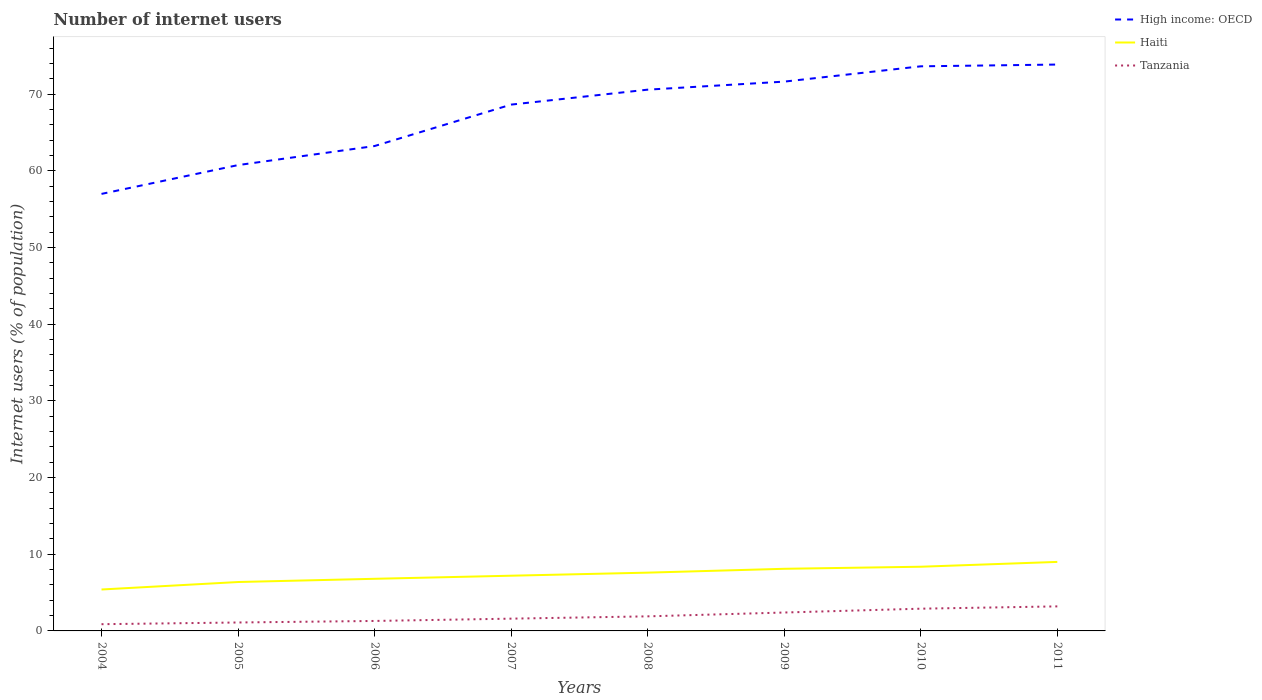How many different coloured lines are there?
Offer a terse response. 3. Does the line corresponding to High income: OECD intersect with the line corresponding to Haiti?
Your answer should be compact. No. Is the number of lines equal to the number of legend labels?
Your answer should be very brief. Yes. Across all years, what is the maximum number of internet users in High income: OECD?
Provide a short and direct response. 56.99. What is the total number of internet users in High income: OECD in the graph?
Your answer should be very brief. -0.23. What is the difference between the highest and the second highest number of internet users in High income: OECD?
Provide a short and direct response. 16.87. Are the values on the major ticks of Y-axis written in scientific E-notation?
Offer a very short reply. No. How many legend labels are there?
Offer a very short reply. 3. How are the legend labels stacked?
Keep it short and to the point. Vertical. What is the title of the graph?
Give a very brief answer. Number of internet users. Does "Morocco" appear as one of the legend labels in the graph?
Provide a short and direct response. No. What is the label or title of the X-axis?
Give a very brief answer. Years. What is the label or title of the Y-axis?
Ensure brevity in your answer.  Internet users (% of population). What is the Internet users (% of population) of High income: OECD in 2004?
Offer a very short reply. 56.99. What is the Internet users (% of population) of Haiti in 2004?
Your answer should be very brief. 5.4. What is the Internet users (% of population) of Tanzania in 2004?
Your answer should be very brief. 0.88. What is the Internet users (% of population) in High income: OECD in 2005?
Ensure brevity in your answer.  60.74. What is the Internet users (% of population) of Haiti in 2005?
Provide a succinct answer. 6.38. What is the Internet users (% of population) in Tanzania in 2005?
Provide a succinct answer. 1.1. What is the Internet users (% of population) in High income: OECD in 2006?
Your answer should be compact. 63.23. What is the Internet users (% of population) in Haiti in 2006?
Ensure brevity in your answer.  6.8. What is the Internet users (% of population) of High income: OECD in 2007?
Offer a terse response. 68.63. What is the Internet users (% of population) in High income: OECD in 2008?
Your answer should be compact. 70.58. What is the Internet users (% of population) of Tanzania in 2008?
Your response must be concise. 1.9. What is the Internet users (% of population) in High income: OECD in 2009?
Offer a very short reply. 71.63. What is the Internet users (% of population) in High income: OECD in 2010?
Offer a terse response. 73.62. What is the Internet users (% of population) in Haiti in 2010?
Your answer should be compact. 8.37. What is the Internet users (% of population) of High income: OECD in 2011?
Provide a succinct answer. 73.85. What is the Internet users (% of population) in Haiti in 2011?
Your response must be concise. 9. What is the Internet users (% of population) of Tanzania in 2011?
Provide a short and direct response. 3.2. Across all years, what is the maximum Internet users (% of population) of High income: OECD?
Your response must be concise. 73.85. Across all years, what is the maximum Internet users (% of population) of Tanzania?
Make the answer very short. 3.2. Across all years, what is the minimum Internet users (% of population) in High income: OECD?
Your answer should be very brief. 56.99. Across all years, what is the minimum Internet users (% of population) of Haiti?
Your answer should be very brief. 5.4. Across all years, what is the minimum Internet users (% of population) of Tanzania?
Provide a succinct answer. 0.88. What is the total Internet users (% of population) in High income: OECD in the graph?
Make the answer very short. 539.27. What is the total Internet users (% of population) of Haiti in the graph?
Provide a succinct answer. 58.84. What is the total Internet users (% of population) in Tanzania in the graph?
Provide a short and direct response. 15.28. What is the difference between the Internet users (% of population) of High income: OECD in 2004 and that in 2005?
Keep it short and to the point. -3.76. What is the difference between the Internet users (% of population) in Haiti in 2004 and that in 2005?
Give a very brief answer. -0.97. What is the difference between the Internet users (% of population) in Tanzania in 2004 and that in 2005?
Keep it short and to the point. -0.22. What is the difference between the Internet users (% of population) of High income: OECD in 2004 and that in 2006?
Your answer should be compact. -6.24. What is the difference between the Internet users (% of population) in Haiti in 2004 and that in 2006?
Keep it short and to the point. -1.39. What is the difference between the Internet users (% of population) of Tanzania in 2004 and that in 2006?
Offer a terse response. -0.42. What is the difference between the Internet users (% of population) of High income: OECD in 2004 and that in 2007?
Give a very brief answer. -11.64. What is the difference between the Internet users (% of population) of Haiti in 2004 and that in 2007?
Keep it short and to the point. -1.8. What is the difference between the Internet users (% of population) in Tanzania in 2004 and that in 2007?
Your answer should be very brief. -0.72. What is the difference between the Internet users (% of population) in High income: OECD in 2004 and that in 2008?
Make the answer very short. -13.59. What is the difference between the Internet users (% of population) of Haiti in 2004 and that in 2008?
Your answer should be very brief. -2.2. What is the difference between the Internet users (% of population) in Tanzania in 2004 and that in 2008?
Offer a terse response. -1.02. What is the difference between the Internet users (% of population) in High income: OECD in 2004 and that in 2009?
Provide a short and direct response. -14.64. What is the difference between the Internet users (% of population) in Haiti in 2004 and that in 2009?
Make the answer very short. -2.7. What is the difference between the Internet users (% of population) of Tanzania in 2004 and that in 2009?
Your answer should be very brief. -1.52. What is the difference between the Internet users (% of population) of High income: OECD in 2004 and that in 2010?
Give a very brief answer. -16.64. What is the difference between the Internet users (% of population) of Haiti in 2004 and that in 2010?
Give a very brief answer. -2.97. What is the difference between the Internet users (% of population) of Tanzania in 2004 and that in 2010?
Provide a short and direct response. -2.02. What is the difference between the Internet users (% of population) in High income: OECD in 2004 and that in 2011?
Your answer should be compact. -16.87. What is the difference between the Internet users (% of population) of Haiti in 2004 and that in 2011?
Your answer should be compact. -3.6. What is the difference between the Internet users (% of population) in Tanzania in 2004 and that in 2011?
Give a very brief answer. -2.32. What is the difference between the Internet users (% of population) of High income: OECD in 2005 and that in 2006?
Your answer should be very brief. -2.49. What is the difference between the Internet users (% of population) in Haiti in 2005 and that in 2006?
Your answer should be very brief. -0.42. What is the difference between the Internet users (% of population) in High income: OECD in 2005 and that in 2007?
Provide a short and direct response. -7.89. What is the difference between the Internet users (% of population) of Haiti in 2005 and that in 2007?
Keep it short and to the point. -0.82. What is the difference between the Internet users (% of population) of High income: OECD in 2005 and that in 2008?
Your answer should be very brief. -9.84. What is the difference between the Internet users (% of population) in Haiti in 2005 and that in 2008?
Ensure brevity in your answer.  -1.22. What is the difference between the Internet users (% of population) in High income: OECD in 2005 and that in 2009?
Make the answer very short. -10.88. What is the difference between the Internet users (% of population) of Haiti in 2005 and that in 2009?
Your response must be concise. -1.72. What is the difference between the Internet users (% of population) of Tanzania in 2005 and that in 2009?
Offer a very short reply. -1.3. What is the difference between the Internet users (% of population) of High income: OECD in 2005 and that in 2010?
Your response must be concise. -12.88. What is the difference between the Internet users (% of population) in Haiti in 2005 and that in 2010?
Provide a succinct answer. -1.99. What is the difference between the Internet users (% of population) in Tanzania in 2005 and that in 2010?
Your response must be concise. -1.8. What is the difference between the Internet users (% of population) of High income: OECD in 2005 and that in 2011?
Give a very brief answer. -13.11. What is the difference between the Internet users (% of population) in Haiti in 2005 and that in 2011?
Your answer should be compact. -2.62. What is the difference between the Internet users (% of population) of High income: OECD in 2006 and that in 2007?
Provide a succinct answer. -5.4. What is the difference between the Internet users (% of population) of Haiti in 2006 and that in 2007?
Provide a succinct answer. -0.4. What is the difference between the Internet users (% of population) of High income: OECD in 2006 and that in 2008?
Ensure brevity in your answer.  -7.35. What is the difference between the Internet users (% of population) of Haiti in 2006 and that in 2008?
Keep it short and to the point. -0.8. What is the difference between the Internet users (% of population) of Tanzania in 2006 and that in 2008?
Your answer should be very brief. -0.6. What is the difference between the Internet users (% of population) in High income: OECD in 2006 and that in 2009?
Keep it short and to the point. -8.4. What is the difference between the Internet users (% of population) of Haiti in 2006 and that in 2009?
Offer a very short reply. -1.3. What is the difference between the Internet users (% of population) of Tanzania in 2006 and that in 2009?
Offer a terse response. -1.1. What is the difference between the Internet users (% of population) of High income: OECD in 2006 and that in 2010?
Provide a short and direct response. -10.39. What is the difference between the Internet users (% of population) of Haiti in 2006 and that in 2010?
Keep it short and to the point. -1.57. What is the difference between the Internet users (% of population) of Tanzania in 2006 and that in 2010?
Give a very brief answer. -1.6. What is the difference between the Internet users (% of population) in High income: OECD in 2006 and that in 2011?
Your answer should be very brief. -10.62. What is the difference between the Internet users (% of population) in Haiti in 2006 and that in 2011?
Offer a very short reply. -2.2. What is the difference between the Internet users (% of population) of Tanzania in 2006 and that in 2011?
Your answer should be compact. -1.9. What is the difference between the Internet users (% of population) in High income: OECD in 2007 and that in 2008?
Your answer should be compact. -1.95. What is the difference between the Internet users (% of population) in Haiti in 2007 and that in 2008?
Ensure brevity in your answer.  -0.4. What is the difference between the Internet users (% of population) in Tanzania in 2007 and that in 2008?
Provide a short and direct response. -0.3. What is the difference between the Internet users (% of population) of High income: OECD in 2007 and that in 2009?
Provide a short and direct response. -3. What is the difference between the Internet users (% of population) of High income: OECD in 2007 and that in 2010?
Give a very brief answer. -4.99. What is the difference between the Internet users (% of population) in Haiti in 2007 and that in 2010?
Give a very brief answer. -1.17. What is the difference between the Internet users (% of population) of High income: OECD in 2007 and that in 2011?
Ensure brevity in your answer.  -5.22. What is the difference between the Internet users (% of population) of Haiti in 2007 and that in 2011?
Ensure brevity in your answer.  -1.8. What is the difference between the Internet users (% of population) in High income: OECD in 2008 and that in 2009?
Provide a short and direct response. -1.05. What is the difference between the Internet users (% of population) in High income: OECD in 2008 and that in 2010?
Provide a succinct answer. -3.04. What is the difference between the Internet users (% of population) of Haiti in 2008 and that in 2010?
Ensure brevity in your answer.  -0.77. What is the difference between the Internet users (% of population) in High income: OECD in 2008 and that in 2011?
Offer a very short reply. -3.27. What is the difference between the Internet users (% of population) in Tanzania in 2008 and that in 2011?
Offer a terse response. -1.3. What is the difference between the Internet users (% of population) in High income: OECD in 2009 and that in 2010?
Your answer should be compact. -2. What is the difference between the Internet users (% of population) in Haiti in 2009 and that in 2010?
Ensure brevity in your answer.  -0.27. What is the difference between the Internet users (% of population) of High income: OECD in 2009 and that in 2011?
Your response must be concise. -2.23. What is the difference between the Internet users (% of population) of High income: OECD in 2010 and that in 2011?
Provide a succinct answer. -0.23. What is the difference between the Internet users (% of population) in Haiti in 2010 and that in 2011?
Make the answer very short. -0.63. What is the difference between the Internet users (% of population) of Tanzania in 2010 and that in 2011?
Offer a terse response. -0.3. What is the difference between the Internet users (% of population) of High income: OECD in 2004 and the Internet users (% of population) of Haiti in 2005?
Your answer should be compact. 50.61. What is the difference between the Internet users (% of population) of High income: OECD in 2004 and the Internet users (% of population) of Tanzania in 2005?
Provide a short and direct response. 55.89. What is the difference between the Internet users (% of population) of Haiti in 2004 and the Internet users (% of population) of Tanzania in 2005?
Ensure brevity in your answer.  4.3. What is the difference between the Internet users (% of population) in High income: OECD in 2004 and the Internet users (% of population) in Haiti in 2006?
Provide a succinct answer. 50.19. What is the difference between the Internet users (% of population) of High income: OECD in 2004 and the Internet users (% of population) of Tanzania in 2006?
Provide a short and direct response. 55.69. What is the difference between the Internet users (% of population) of Haiti in 2004 and the Internet users (% of population) of Tanzania in 2006?
Offer a terse response. 4.1. What is the difference between the Internet users (% of population) in High income: OECD in 2004 and the Internet users (% of population) in Haiti in 2007?
Your response must be concise. 49.79. What is the difference between the Internet users (% of population) in High income: OECD in 2004 and the Internet users (% of population) in Tanzania in 2007?
Offer a very short reply. 55.39. What is the difference between the Internet users (% of population) of Haiti in 2004 and the Internet users (% of population) of Tanzania in 2007?
Provide a short and direct response. 3.8. What is the difference between the Internet users (% of population) in High income: OECD in 2004 and the Internet users (% of population) in Haiti in 2008?
Ensure brevity in your answer.  49.39. What is the difference between the Internet users (% of population) of High income: OECD in 2004 and the Internet users (% of population) of Tanzania in 2008?
Ensure brevity in your answer.  55.09. What is the difference between the Internet users (% of population) in Haiti in 2004 and the Internet users (% of population) in Tanzania in 2008?
Give a very brief answer. 3.5. What is the difference between the Internet users (% of population) in High income: OECD in 2004 and the Internet users (% of population) in Haiti in 2009?
Offer a very short reply. 48.89. What is the difference between the Internet users (% of population) in High income: OECD in 2004 and the Internet users (% of population) in Tanzania in 2009?
Make the answer very short. 54.59. What is the difference between the Internet users (% of population) of Haiti in 2004 and the Internet users (% of population) of Tanzania in 2009?
Provide a short and direct response. 3. What is the difference between the Internet users (% of population) in High income: OECD in 2004 and the Internet users (% of population) in Haiti in 2010?
Provide a succinct answer. 48.62. What is the difference between the Internet users (% of population) in High income: OECD in 2004 and the Internet users (% of population) in Tanzania in 2010?
Ensure brevity in your answer.  54.09. What is the difference between the Internet users (% of population) of Haiti in 2004 and the Internet users (% of population) of Tanzania in 2010?
Your response must be concise. 2.5. What is the difference between the Internet users (% of population) in High income: OECD in 2004 and the Internet users (% of population) in Haiti in 2011?
Provide a succinct answer. 47.99. What is the difference between the Internet users (% of population) of High income: OECD in 2004 and the Internet users (% of population) of Tanzania in 2011?
Offer a very short reply. 53.79. What is the difference between the Internet users (% of population) in Haiti in 2004 and the Internet users (% of population) in Tanzania in 2011?
Ensure brevity in your answer.  2.2. What is the difference between the Internet users (% of population) in High income: OECD in 2005 and the Internet users (% of population) in Haiti in 2006?
Keep it short and to the point. 53.95. What is the difference between the Internet users (% of population) in High income: OECD in 2005 and the Internet users (% of population) in Tanzania in 2006?
Offer a terse response. 59.44. What is the difference between the Internet users (% of population) in Haiti in 2005 and the Internet users (% of population) in Tanzania in 2006?
Your answer should be very brief. 5.08. What is the difference between the Internet users (% of population) in High income: OECD in 2005 and the Internet users (% of population) in Haiti in 2007?
Ensure brevity in your answer.  53.54. What is the difference between the Internet users (% of population) of High income: OECD in 2005 and the Internet users (% of population) of Tanzania in 2007?
Your answer should be very brief. 59.14. What is the difference between the Internet users (% of population) of Haiti in 2005 and the Internet users (% of population) of Tanzania in 2007?
Your answer should be compact. 4.78. What is the difference between the Internet users (% of population) of High income: OECD in 2005 and the Internet users (% of population) of Haiti in 2008?
Make the answer very short. 53.14. What is the difference between the Internet users (% of population) in High income: OECD in 2005 and the Internet users (% of population) in Tanzania in 2008?
Your answer should be very brief. 58.84. What is the difference between the Internet users (% of population) of Haiti in 2005 and the Internet users (% of population) of Tanzania in 2008?
Ensure brevity in your answer.  4.48. What is the difference between the Internet users (% of population) of High income: OECD in 2005 and the Internet users (% of population) of Haiti in 2009?
Your answer should be very brief. 52.64. What is the difference between the Internet users (% of population) in High income: OECD in 2005 and the Internet users (% of population) in Tanzania in 2009?
Keep it short and to the point. 58.34. What is the difference between the Internet users (% of population) in Haiti in 2005 and the Internet users (% of population) in Tanzania in 2009?
Your answer should be compact. 3.98. What is the difference between the Internet users (% of population) of High income: OECD in 2005 and the Internet users (% of population) of Haiti in 2010?
Provide a short and direct response. 52.37. What is the difference between the Internet users (% of population) in High income: OECD in 2005 and the Internet users (% of population) in Tanzania in 2010?
Provide a short and direct response. 57.84. What is the difference between the Internet users (% of population) of Haiti in 2005 and the Internet users (% of population) of Tanzania in 2010?
Your answer should be compact. 3.48. What is the difference between the Internet users (% of population) in High income: OECD in 2005 and the Internet users (% of population) in Haiti in 2011?
Provide a short and direct response. 51.74. What is the difference between the Internet users (% of population) of High income: OECD in 2005 and the Internet users (% of population) of Tanzania in 2011?
Make the answer very short. 57.54. What is the difference between the Internet users (% of population) of Haiti in 2005 and the Internet users (% of population) of Tanzania in 2011?
Provide a short and direct response. 3.18. What is the difference between the Internet users (% of population) of High income: OECD in 2006 and the Internet users (% of population) of Haiti in 2007?
Provide a short and direct response. 56.03. What is the difference between the Internet users (% of population) in High income: OECD in 2006 and the Internet users (% of population) in Tanzania in 2007?
Make the answer very short. 61.63. What is the difference between the Internet users (% of population) in Haiti in 2006 and the Internet users (% of population) in Tanzania in 2007?
Offer a terse response. 5.2. What is the difference between the Internet users (% of population) in High income: OECD in 2006 and the Internet users (% of population) in Haiti in 2008?
Keep it short and to the point. 55.63. What is the difference between the Internet users (% of population) in High income: OECD in 2006 and the Internet users (% of population) in Tanzania in 2008?
Give a very brief answer. 61.33. What is the difference between the Internet users (% of population) of Haiti in 2006 and the Internet users (% of population) of Tanzania in 2008?
Give a very brief answer. 4.9. What is the difference between the Internet users (% of population) of High income: OECD in 2006 and the Internet users (% of population) of Haiti in 2009?
Offer a very short reply. 55.13. What is the difference between the Internet users (% of population) of High income: OECD in 2006 and the Internet users (% of population) of Tanzania in 2009?
Your answer should be compact. 60.83. What is the difference between the Internet users (% of population) of Haiti in 2006 and the Internet users (% of population) of Tanzania in 2009?
Give a very brief answer. 4.4. What is the difference between the Internet users (% of population) in High income: OECD in 2006 and the Internet users (% of population) in Haiti in 2010?
Your response must be concise. 54.86. What is the difference between the Internet users (% of population) in High income: OECD in 2006 and the Internet users (% of population) in Tanzania in 2010?
Provide a short and direct response. 60.33. What is the difference between the Internet users (% of population) in Haiti in 2006 and the Internet users (% of population) in Tanzania in 2010?
Offer a terse response. 3.9. What is the difference between the Internet users (% of population) in High income: OECD in 2006 and the Internet users (% of population) in Haiti in 2011?
Give a very brief answer. 54.23. What is the difference between the Internet users (% of population) in High income: OECD in 2006 and the Internet users (% of population) in Tanzania in 2011?
Provide a short and direct response. 60.03. What is the difference between the Internet users (% of population) of Haiti in 2006 and the Internet users (% of population) of Tanzania in 2011?
Your answer should be very brief. 3.6. What is the difference between the Internet users (% of population) of High income: OECD in 2007 and the Internet users (% of population) of Haiti in 2008?
Your answer should be compact. 61.03. What is the difference between the Internet users (% of population) of High income: OECD in 2007 and the Internet users (% of population) of Tanzania in 2008?
Make the answer very short. 66.73. What is the difference between the Internet users (% of population) in High income: OECD in 2007 and the Internet users (% of population) in Haiti in 2009?
Give a very brief answer. 60.53. What is the difference between the Internet users (% of population) of High income: OECD in 2007 and the Internet users (% of population) of Tanzania in 2009?
Offer a very short reply. 66.23. What is the difference between the Internet users (% of population) in Haiti in 2007 and the Internet users (% of population) in Tanzania in 2009?
Keep it short and to the point. 4.8. What is the difference between the Internet users (% of population) in High income: OECD in 2007 and the Internet users (% of population) in Haiti in 2010?
Give a very brief answer. 60.26. What is the difference between the Internet users (% of population) in High income: OECD in 2007 and the Internet users (% of population) in Tanzania in 2010?
Keep it short and to the point. 65.73. What is the difference between the Internet users (% of population) of Haiti in 2007 and the Internet users (% of population) of Tanzania in 2010?
Offer a very short reply. 4.3. What is the difference between the Internet users (% of population) of High income: OECD in 2007 and the Internet users (% of population) of Haiti in 2011?
Offer a terse response. 59.63. What is the difference between the Internet users (% of population) of High income: OECD in 2007 and the Internet users (% of population) of Tanzania in 2011?
Make the answer very short. 65.43. What is the difference between the Internet users (% of population) in High income: OECD in 2008 and the Internet users (% of population) in Haiti in 2009?
Make the answer very short. 62.48. What is the difference between the Internet users (% of population) of High income: OECD in 2008 and the Internet users (% of population) of Tanzania in 2009?
Your answer should be compact. 68.18. What is the difference between the Internet users (% of population) in Haiti in 2008 and the Internet users (% of population) in Tanzania in 2009?
Make the answer very short. 5.2. What is the difference between the Internet users (% of population) in High income: OECD in 2008 and the Internet users (% of population) in Haiti in 2010?
Give a very brief answer. 62.21. What is the difference between the Internet users (% of population) of High income: OECD in 2008 and the Internet users (% of population) of Tanzania in 2010?
Your response must be concise. 67.68. What is the difference between the Internet users (% of population) in High income: OECD in 2008 and the Internet users (% of population) in Haiti in 2011?
Offer a very short reply. 61.58. What is the difference between the Internet users (% of population) in High income: OECD in 2008 and the Internet users (% of population) in Tanzania in 2011?
Offer a very short reply. 67.38. What is the difference between the Internet users (% of population) in Haiti in 2008 and the Internet users (% of population) in Tanzania in 2011?
Your answer should be very brief. 4.4. What is the difference between the Internet users (% of population) of High income: OECD in 2009 and the Internet users (% of population) of Haiti in 2010?
Ensure brevity in your answer.  63.26. What is the difference between the Internet users (% of population) of High income: OECD in 2009 and the Internet users (% of population) of Tanzania in 2010?
Offer a very short reply. 68.73. What is the difference between the Internet users (% of population) of High income: OECD in 2009 and the Internet users (% of population) of Haiti in 2011?
Your answer should be compact. 62.63. What is the difference between the Internet users (% of population) in High income: OECD in 2009 and the Internet users (% of population) in Tanzania in 2011?
Provide a succinct answer. 68.43. What is the difference between the Internet users (% of population) of Haiti in 2009 and the Internet users (% of population) of Tanzania in 2011?
Keep it short and to the point. 4.9. What is the difference between the Internet users (% of population) of High income: OECD in 2010 and the Internet users (% of population) of Haiti in 2011?
Your answer should be compact. 64.62. What is the difference between the Internet users (% of population) of High income: OECD in 2010 and the Internet users (% of population) of Tanzania in 2011?
Provide a short and direct response. 70.42. What is the difference between the Internet users (% of population) of Haiti in 2010 and the Internet users (% of population) of Tanzania in 2011?
Offer a terse response. 5.17. What is the average Internet users (% of population) in High income: OECD per year?
Give a very brief answer. 67.41. What is the average Internet users (% of population) of Haiti per year?
Provide a succinct answer. 7.36. What is the average Internet users (% of population) in Tanzania per year?
Provide a succinct answer. 1.91. In the year 2004, what is the difference between the Internet users (% of population) of High income: OECD and Internet users (% of population) of Haiti?
Ensure brevity in your answer.  51.58. In the year 2004, what is the difference between the Internet users (% of population) of High income: OECD and Internet users (% of population) of Tanzania?
Provide a succinct answer. 56.11. In the year 2004, what is the difference between the Internet users (% of population) in Haiti and Internet users (% of population) in Tanzania?
Your answer should be very brief. 4.52. In the year 2005, what is the difference between the Internet users (% of population) in High income: OECD and Internet users (% of population) in Haiti?
Offer a very short reply. 54.37. In the year 2005, what is the difference between the Internet users (% of population) of High income: OECD and Internet users (% of population) of Tanzania?
Give a very brief answer. 59.64. In the year 2005, what is the difference between the Internet users (% of population) in Haiti and Internet users (% of population) in Tanzania?
Your response must be concise. 5.28. In the year 2006, what is the difference between the Internet users (% of population) of High income: OECD and Internet users (% of population) of Haiti?
Your answer should be very brief. 56.43. In the year 2006, what is the difference between the Internet users (% of population) in High income: OECD and Internet users (% of population) in Tanzania?
Make the answer very short. 61.93. In the year 2006, what is the difference between the Internet users (% of population) of Haiti and Internet users (% of population) of Tanzania?
Your answer should be very brief. 5.5. In the year 2007, what is the difference between the Internet users (% of population) in High income: OECD and Internet users (% of population) in Haiti?
Your answer should be compact. 61.43. In the year 2007, what is the difference between the Internet users (% of population) of High income: OECD and Internet users (% of population) of Tanzania?
Your answer should be very brief. 67.03. In the year 2008, what is the difference between the Internet users (% of population) in High income: OECD and Internet users (% of population) in Haiti?
Keep it short and to the point. 62.98. In the year 2008, what is the difference between the Internet users (% of population) in High income: OECD and Internet users (% of population) in Tanzania?
Your answer should be very brief. 68.68. In the year 2009, what is the difference between the Internet users (% of population) in High income: OECD and Internet users (% of population) in Haiti?
Provide a short and direct response. 63.53. In the year 2009, what is the difference between the Internet users (% of population) in High income: OECD and Internet users (% of population) in Tanzania?
Offer a very short reply. 69.23. In the year 2009, what is the difference between the Internet users (% of population) in Haiti and Internet users (% of population) in Tanzania?
Provide a succinct answer. 5.7. In the year 2010, what is the difference between the Internet users (% of population) of High income: OECD and Internet users (% of population) of Haiti?
Provide a short and direct response. 65.25. In the year 2010, what is the difference between the Internet users (% of population) of High income: OECD and Internet users (% of population) of Tanzania?
Offer a terse response. 70.72. In the year 2010, what is the difference between the Internet users (% of population) of Haiti and Internet users (% of population) of Tanzania?
Offer a terse response. 5.47. In the year 2011, what is the difference between the Internet users (% of population) of High income: OECD and Internet users (% of population) of Haiti?
Your answer should be very brief. 64.85. In the year 2011, what is the difference between the Internet users (% of population) of High income: OECD and Internet users (% of population) of Tanzania?
Your response must be concise. 70.65. What is the ratio of the Internet users (% of population) in High income: OECD in 2004 to that in 2005?
Provide a short and direct response. 0.94. What is the ratio of the Internet users (% of population) in Haiti in 2004 to that in 2005?
Your response must be concise. 0.85. What is the ratio of the Internet users (% of population) of Tanzania in 2004 to that in 2005?
Provide a short and direct response. 0.8. What is the ratio of the Internet users (% of population) in High income: OECD in 2004 to that in 2006?
Ensure brevity in your answer.  0.9. What is the ratio of the Internet users (% of population) in Haiti in 2004 to that in 2006?
Your answer should be compact. 0.79. What is the ratio of the Internet users (% of population) in Tanzania in 2004 to that in 2006?
Your answer should be compact. 0.68. What is the ratio of the Internet users (% of population) in High income: OECD in 2004 to that in 2007?
Offer a terse response. 0.83. What is the ratio of the Internet users (% of population) in Haiti in 2004 to that in 2007?
Ensure brevity in your answer.  0.75. What is the ratio of the Internet users (% of population) in Tanzania in 2004 to that in 2007?
Offer a terse response. 0.55. What is the ratio of the Internet users (% of population) of High income: OECD in 2004 to that in 2008?
Offer a terse response. 0.81. What is the ratio of the Internet users (% of population) of Haiti in 2004 to that in 2008?
Your response must be concise. 0.71. What is the ratio of the Internet users (% of population) of Tanzania in 2004 to that in 2008?
Provide a short and direct response. 0.46. What is the ratio of the Internet users (% of population) in High income: OECD in 2004 to that in 2009?
Offer a very short reply. 0.8. What is the ratio of the Internet users (% of population) in Haiti in 2004 to that in 2009?
Your response must be concise. 0.67. What is the ratio of the Internet users (% of population) of Tanzania in 2004 to that in 2009?
Offer a very short reply. 0.37. What is the ratio of the Internet users (% of population) in High income: OECD in 2004 to that in 2010?
Provide a succinct answer. 0.77. What is the ratio of the Internet users (% of population) of Haiti in 2004 to that in 2010?
Your answer should be compact. 0.65. What is the ratio of the Internet users (% of population) in Tanzania in 2004 to that in 2010?
Your answer should be compact. 0.3. What is the ratio of the Internet users (% of population) of High income: OECD in 2004 to that in 2011?
Offer a terse response. 0.77. What is the ratio of the Internet users (% of population) in Haiti in 2004 to that in 2011?
Provide a succinct answer. 0.6. What is the ratio of the Internet users (% of population) of Tanzania in 2004 to that in 2011?
Make the answer very short. 0.27. What is the ratio of the Internet users (% of population) in High income: OECD in 2005 to that in 2006?
Make the answer very short. 0.96. What is the ratio of the Internet users (% of population) of Haiti in 2005 to that in 2006?
Offer a very short reply. 0.94. What is the ratio of the Internet users (% of population) in Tanzania in 2005 to that in 2006?
Your answer should be compact. 0.85. What is the ratio of the Internet users (% of population) of High income: OECD in 2005 to that in 2007?
Provide a short and direct response. 0.89. What is the ratio of the Internet users (% of population) of Haiti in 2005 to that in 2007?
Your answer should be compact. 0.89. What is the ratio of the Internet users (% of population) of Tanzania in 2005 to that in 2007?
Your response must be concise. 0.69. What is the ratio of the Internet users (% of population) in High income: OECD in 2005 to that in 2008?
Ensure brevity in your answer.  0.86. What is the ratio of the Internet users (% of population) of Haiti in 2005 to that in 2008?
Offer a terse response. 0.84. What is the ratio of the Internet users (% of population) of Tanzania in 2005 to that in 2008?
Keep it short and to the point. 0.58. What is the ratio of the Internet users (% of population) of High income: OECD in 2005 to that in 2009?
Keep it short and to the point. 0.85. What is the ratio of the Internet users (% of population) in Haiti in 2005 to that in 2009?
Provide a short and direct response. 0.79. What is the ratio of the Internet users (% of population) of Tanzania in 2005 to that in 2009?
Provide a succinct answer. 0.46. What is the ratio of the Internet users (% of population) of High income: OECD in 2005 to that in 2010?
Your answer should be very brief. 0.83. What is the ratio of the Internet users (% of population) in Haiti in 2005 to that in 2010?
Keep it short and to the point. 0.76. What is the ratio of the Internet users (% of population) in Tanzania in 2005 to that in 2010?
Offer a very short reply. 0.38. What is the ratio of the Internet users (% of population) of High income: OECD in 2005 to that in 2011?
Provide a short and direct response. 0.82. What is the ratio of the Internet users (% of population) of Haiti in 2005 to that in 2011?
Keep it short and to the point. 0.71. What is the ratio of the Internet users (% of population) in Tanzania in 2005 to that in 2011?
Your answer should be compact. 0.34. What is the ratio of the Internet users (% of population) of High income: OECD in 2006 to that in 2007?
Provide a succinct answer. 0.92. What is the ratio of the Internet users (% of population) of Haiti in 2006 to that in 2007?
Your response must be concise. 0.94. What is the ratio of the Internet users (% of population) in Tanzania in 2006 to that in 2007?
Provide a short and direct response. 0.81. What is the ratio of the Internet users (% of population) in High income: OECD in 2006 to that in 2008?
Make the answer very short. 0.9. What is the ratio of the Internet users (% of population) of Haiti in 2006 to that in 2008?
Ensure brevity in your answer.  0.89. What is the ratio of the Internet users (% of population) in Tanzania in 2006 to that in 2008?
Offer a very short reply. 0.68. What is the ratio of the Internet users (% of population) in High income: OECD in 2006 to that in 2009?
Your answer should be very brief. 0.88. What is the ratio of the Internet users (% of population) in Haiti in 2006 to that in 2009?
Your answer should be very brief. 0.84. What is the ratio of the Internet users (% of population) in Tanzania in 2006 to that in 2009?
Provide a short and direct response. 0.54. What is the ratio of the Internet users (% of population) in High income: OECD in 2006 to that in 2010?
Ensure brevity in your answer.  0.86. What is the ratio of the Internet users (% of population) of Haiti in 2006 to that in 2010?
Your answer should be compact. 0.81. What is the ratio of the Internet users (% of population) in Tanzania in 2006 to that in 2010?
Your answer should be compact. 0.45. What is the ratio of the Internet users (% of population) of High income: OECD in 2006 to that in 2011?
Ensure brevity in your answer.  0.86. What is the ratio of the Internet users (% of population) of Haiti in 2006 to that in 2011?
Give a very brief answer. 0.76. What is the ratio of the Internet users (% of population) of Tanzania in 2006 to that in 2011?
Keep it short and to the point. 0.41. What is the ratio of the Internet users (% of population) of High income: OECD in 2007 to that in 2008?
Provide a succinct answer. 0.97. What is the ratio of the Internet users (% of population) of Haiti in 2007 to that in 2008?
Your answer should be compact. 0.95. What is the ratio of the Internet users (% of population) in Tanzania in 2007 to that in 2008?
Ensure brevity in your answer.  0.84. What is the ratio of the Internet users (% of population) in High income: OECD in 2007 to that in 2009?
Offer a very short reply. 0.96. What is the ratio of the Internet users (% of population) of Haiti in 2007 to that in 2009?
Your response must be concise. 0.89. What is the ratio of the Internet users (% of population) in Tanzania in 2007 to that in 2009?
Make the answer very short. 0.67. What is the ratio of the Internet users (% of population) in High income: OECD in 2007 to that in 2010?
Give a very brief answer. 0.93. What is the ratio of the Internet users (% of population) of Haiti in 2007 to that in 2010?
Provide a succinct answer. 0.86. What is the ratio of the Internet users (% of population) in Tanzania in 2007 to that in 2010?
Your response must be concise. 0.55. What is the ratio of the Internet users (% of population) in High income: OECD in 2007 to that in 2011?
Your response must be concise. 0.93. What is the ratio of the Internet users (% of population) of Haiti in 2007 to that in 2011?
Offer a terse response. 0.8. What is the ratio of the Internet users (% of population) of High income: OECD in 2008 to that in 2009?
Your response must be concise. 0.99. What is the ratio of the Internet users (% of population) in Haiti in 2008 to that in 2009?
Provide a short and direct response. 0.94. What is the ratio of the Internet users (% of population) in Tanzania in 2008 to that in 2009?
Give a very brief answer. 0.79. What is the ratio of the Internet users (% of population) in High income: OECD in 2008 to that in 2010?
Keep it short and to the point. 0.96. What is the ratio of the Internet users (% of population) in Haiti in 2008 to that in 2010?
Provide a succinct answer. 0.91. What is the ratio of the Internet users (% of population) in Tanzania in 2008 to that in 2010?
Your answer should be very brief. 0.66. What is the ratio of the Internet users (% of population) in High income: OECD in 2008 to that in 2011?
Keep it short and to the point. 0.96. What is the ratio of the Internet users (% of population) of Haiti in 2008 to that in 2011?
Keep it short and to the point. 0.84. What is the ratio of the Internet users (% of population) of Tanzania in 2008 to that in 2011?
Your answer should be compact. 0.59. What is the ratio of the Internet users (% of population) in High income: OECD in 2009 to that in 2010?
Your answer should be very brief. 0.97. What is the ratio of the Internet users (% of population) in Tanzania in 2009 to that in 2010?
Ensure brevity in your answer.  0.83. What is the ratio of the Internet users (% of population) of High income: OECD in 2009 to that in 2011?
Offer a very short reply. 0.97. What is the ratio of the Internet users (% of population) of Haiti in 2009 to that in 2011?
Keep it short and to the point. 0.9. What is the ratio of the Internet users (% of population) in Tanzania in 2010 to that in 2011?
Make the answer very short. 0.91. What is the difference between the highest and the second highest Internet users (% of population) in High income: OECD?
Your answer should be compact. 0.23. What is the difference between the highest and the second highest Internet users (% of population) in Haiti?
Offer a very short reply. 0.63. What is the difference between the highest and the second highest Internet users (% of population) in Tanzania?
Keep it short and to the point. 0.3. What is the difference between the highest and the lowest Internet users (% of population) in High income: OECD?
Your answer should be very brief. 16.87. What is the difference between the highest and the lowest Internet users (% of population) of Haiti?
Offer a very short reply. 3.6. What is the difference between the highest and the lowest Internet users (% of population) of Tanzania?
Offer a terse response. 2.32. 